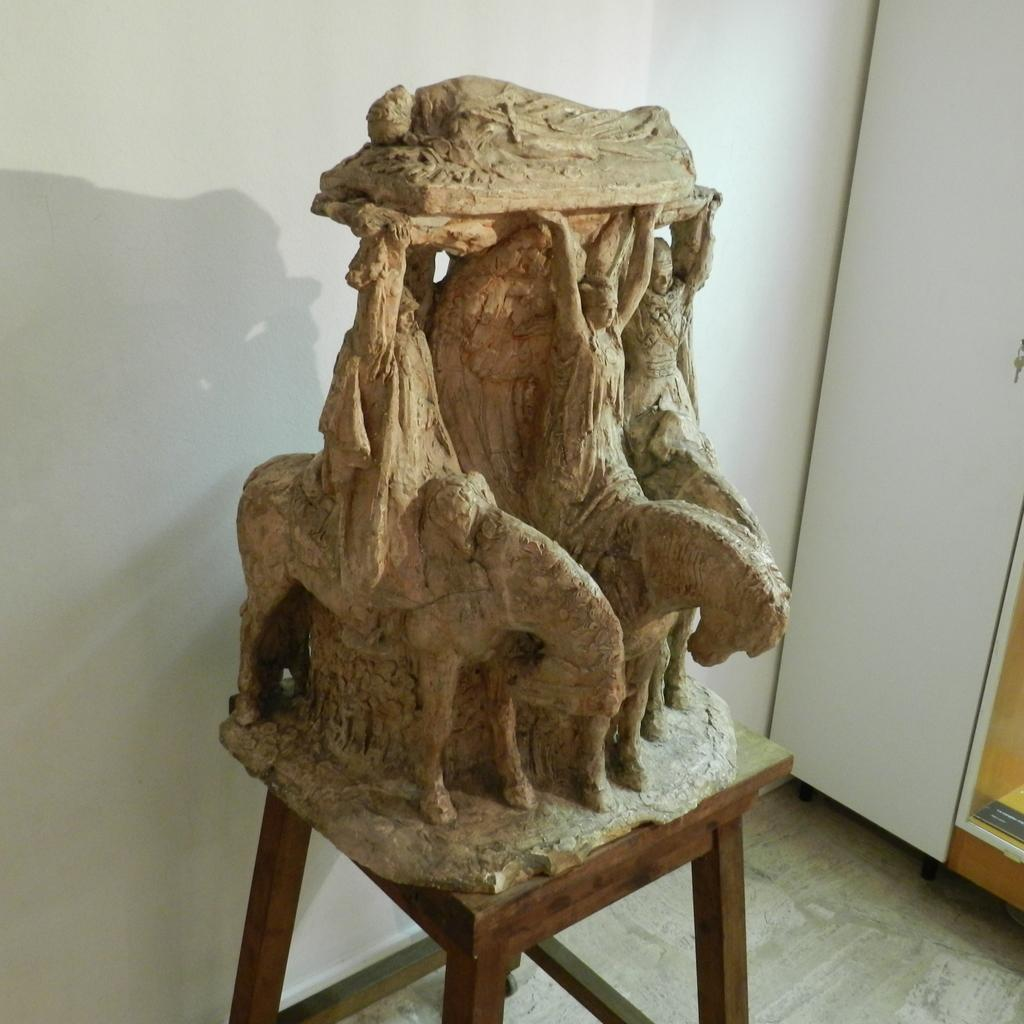What is the main subject of the image? There is a sculpture in the image. How is the sculpture positioned in the image? The sculpture is placed on a wooden stool. What can be seen in the background of the image? There is a white color wall in the background of the image. What type of cast can be seen on the sculpture's arm in the image? There is no cast visible on the sculpture's arm in the image, as the sculpture is not a living being. 